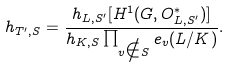Convert formula to latex. <formula><loc_0><loc_0><loc_500><loc_500>h _ { T ^ { \prime } , S } = \frac { h _ { L , S ^ { \prime } } [ H ^ { 1 } ( G , O _ { L , S ^ { \prime } } ^ { * } ) ] } { h _ { K , S } \prod _ { v \notin S } e _ { v } ( L / K ) } .</formula> 